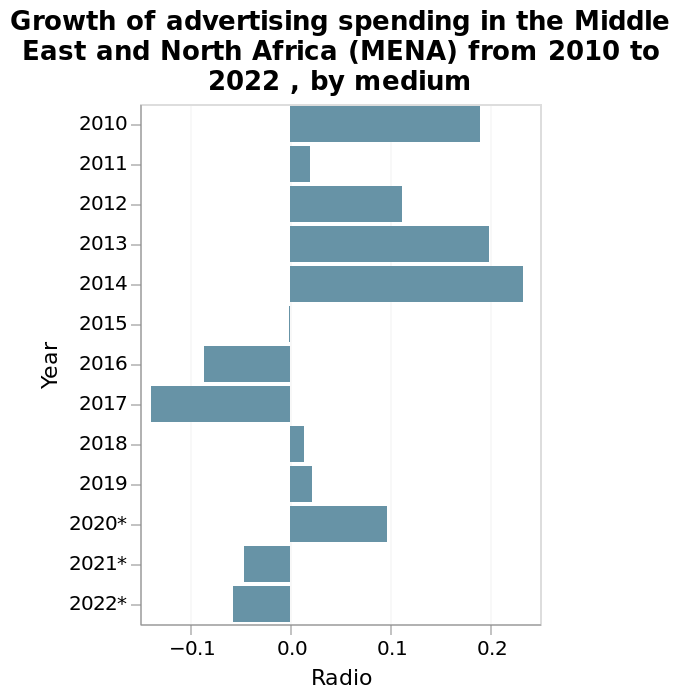<image>
What is the time range covered in the bar plot? The bar plot covers the time range from 2010 to 2022. 